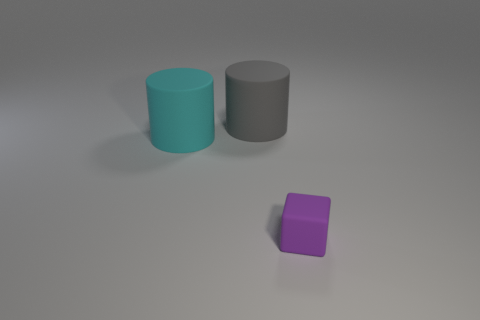Add 2 cyan cylinders. How many objects exist? 5 Subtract all cylinders. How many objects are left? 1 Add 2 big cyan things. How many big cyan things exist? 3 Subtract 0 blue balls. How many objects are left? 3 Subtract all big cyan cylinders. Subtract all small rubber blocks. How many objects are left? 1 Add 2 small purple cubes. How many small purple cubes are left? 3 